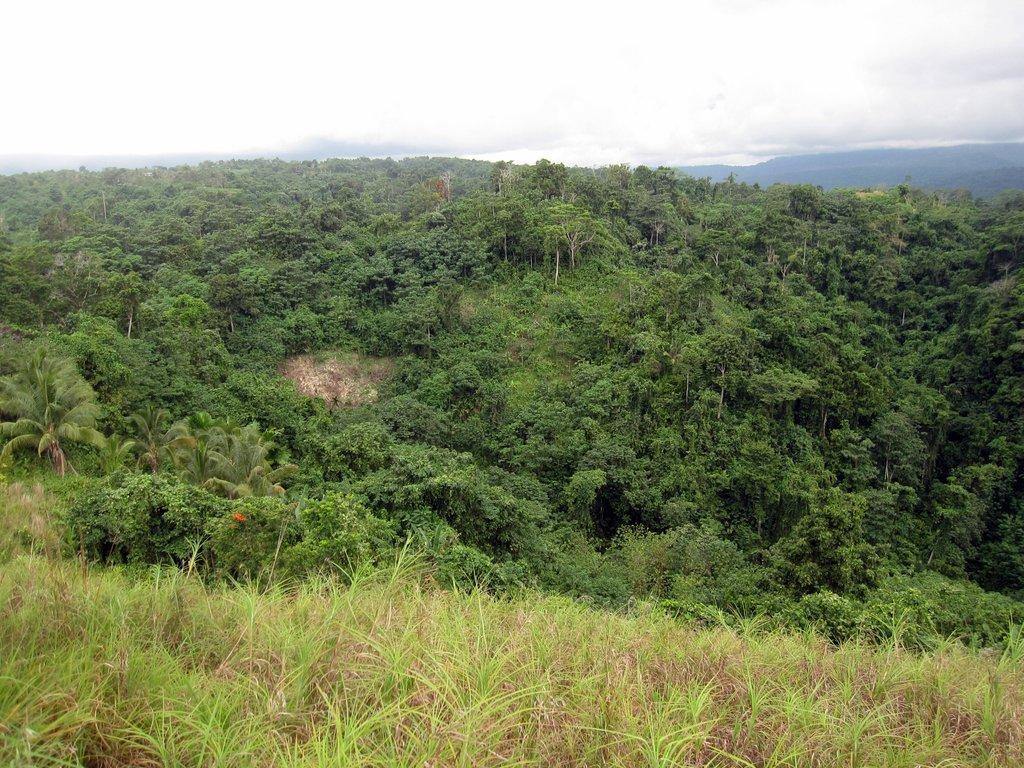How would you summarize this image in a sentence or two? At the bottom of the image there is grass. In the background there are trees, hill and sky. 